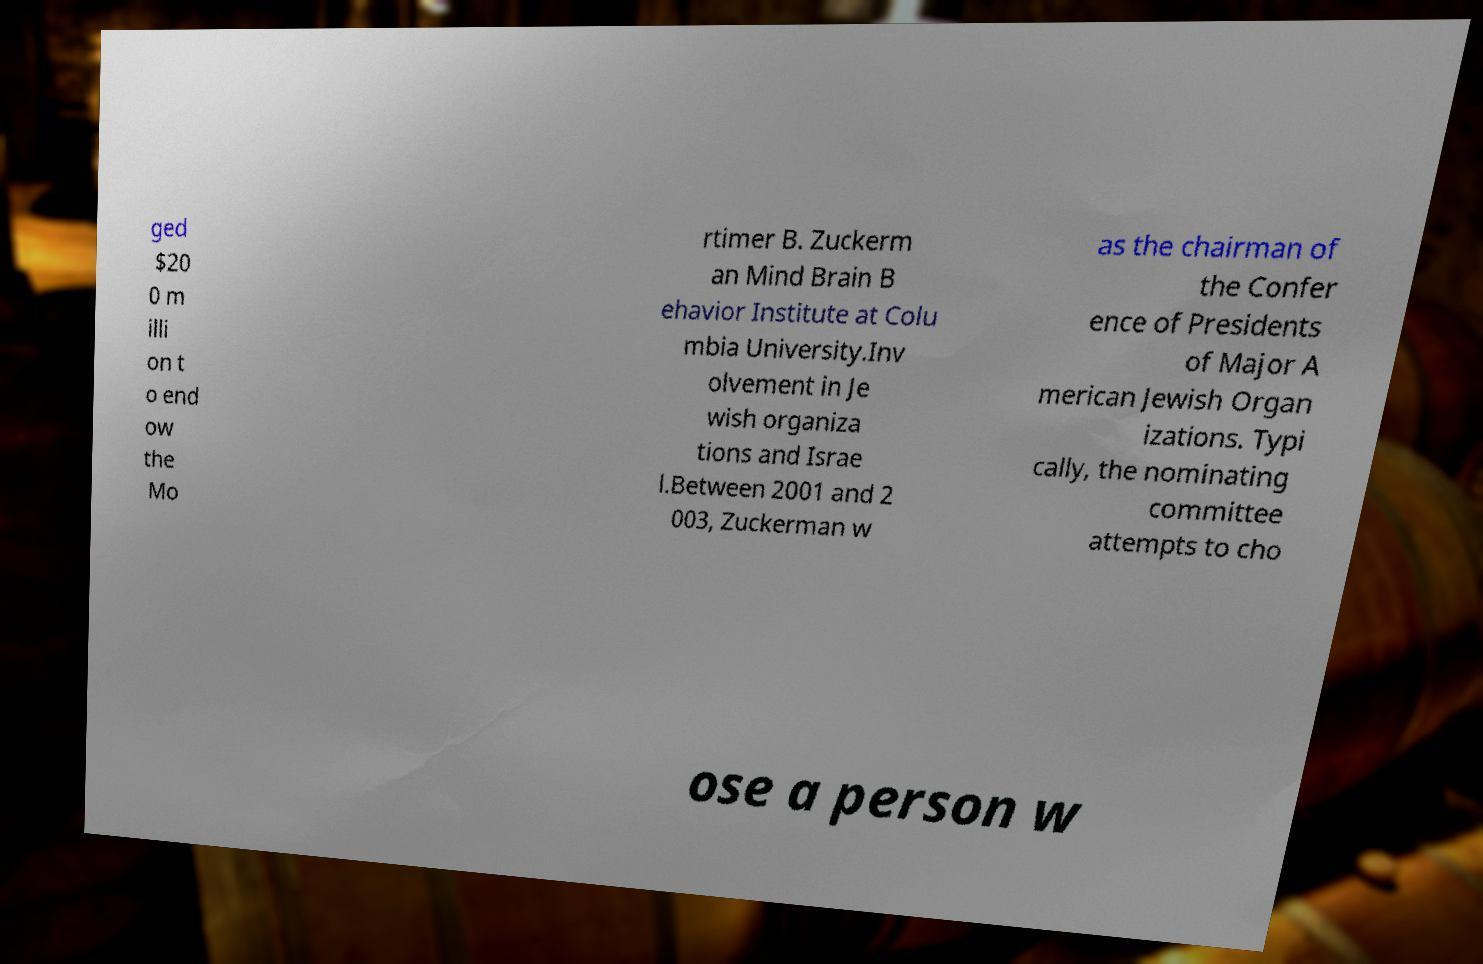Could you assist in decoding the text presented in this image and type it out clearly? ged $20 0 m illi on t o end ow the Mo rtimer B. Zuckerm an Mind Brain B ehavior Institute at Colu mbia University.Inv olvement in Je wish organiza tions and Israe l.Between 2001 and 2 003, Zuckerman w as the chairman of the Confer ence of Presidents of Major A merican Jewish Organ izations. Typi cally, the nominating committee attempts to cho ose a person w 